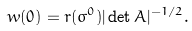<formula> <loc_0><loc_0><loc_500><loc_500>w ( 0 ) = r ( \sigma ^ { 0 } ) | \det A | ^ { - 1 / 2 } .</formula> 